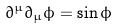Convert formula to latex. <formula><loc_0><loc_0><loc_500><loc_500>\partial ^ { \mu } \partial _ { \mu } \phi = \sin \phi</formula> 